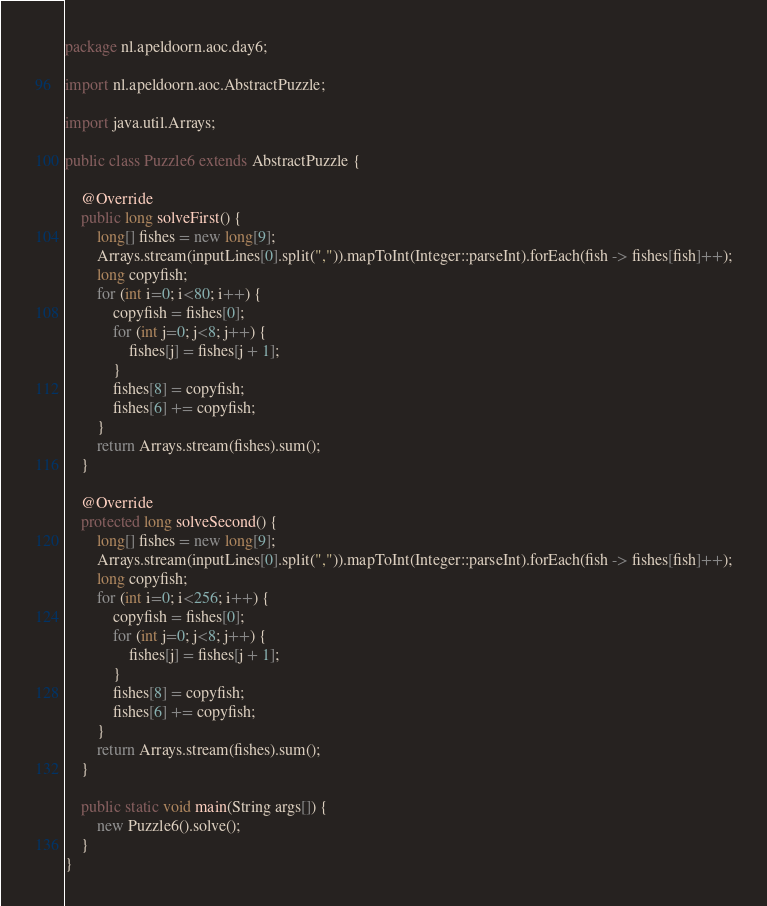<code> <loc_0><loc_0><loc_500><loc_500><_Java_>package nl.apeldoorn.aoc.day6;

import nl.apeldoorn.aoc.AbstractPuzzle;

import java.util.Arrays;

public class Puzzle6 extends AbstractPuzzle {

	@Override
	public long solveFirst() {
		long[] fishes = new long[9];
		Arrays.stream(inputLines[0].split(",")).mapToInt(Integer::parseInt).forEach(fish -> fishes[fish]++);
		long copyfish;
		for (int i=0; i<80; i++) {
			copyfish = fishes[0];
			for (int j=0; j<8; j++) {
				fishes[j] = fishes[j + 1];
			}
			fishes[8] = copyfish;
			fishes[6] += copyfish;
		}
		return Arrays.stream(fishes).sum();
	}

	@Override
	protected long solveSecond() {
		long[] fishes = new long[9];
		Arrays.stream(inputLines[0].split(",")).mapToInt(Integer::parseInt).forEach(fish -> fishes[fish]++);
		long copyfish;
		for (int i=0; i<256; i++) {
			copyfish = fishes[0];
			for (int j=0; j<8; j++) {
				fishes[j] = fishes[j + 1];
			}
			fishes[8] = copyfish;
			fishes[6] += copyfish;
		}
		return Arrays.stream(fishes).sum();
	}

	public static void main(String args[]) {
		new Puzzle6().solve();
	}
}
</code> 